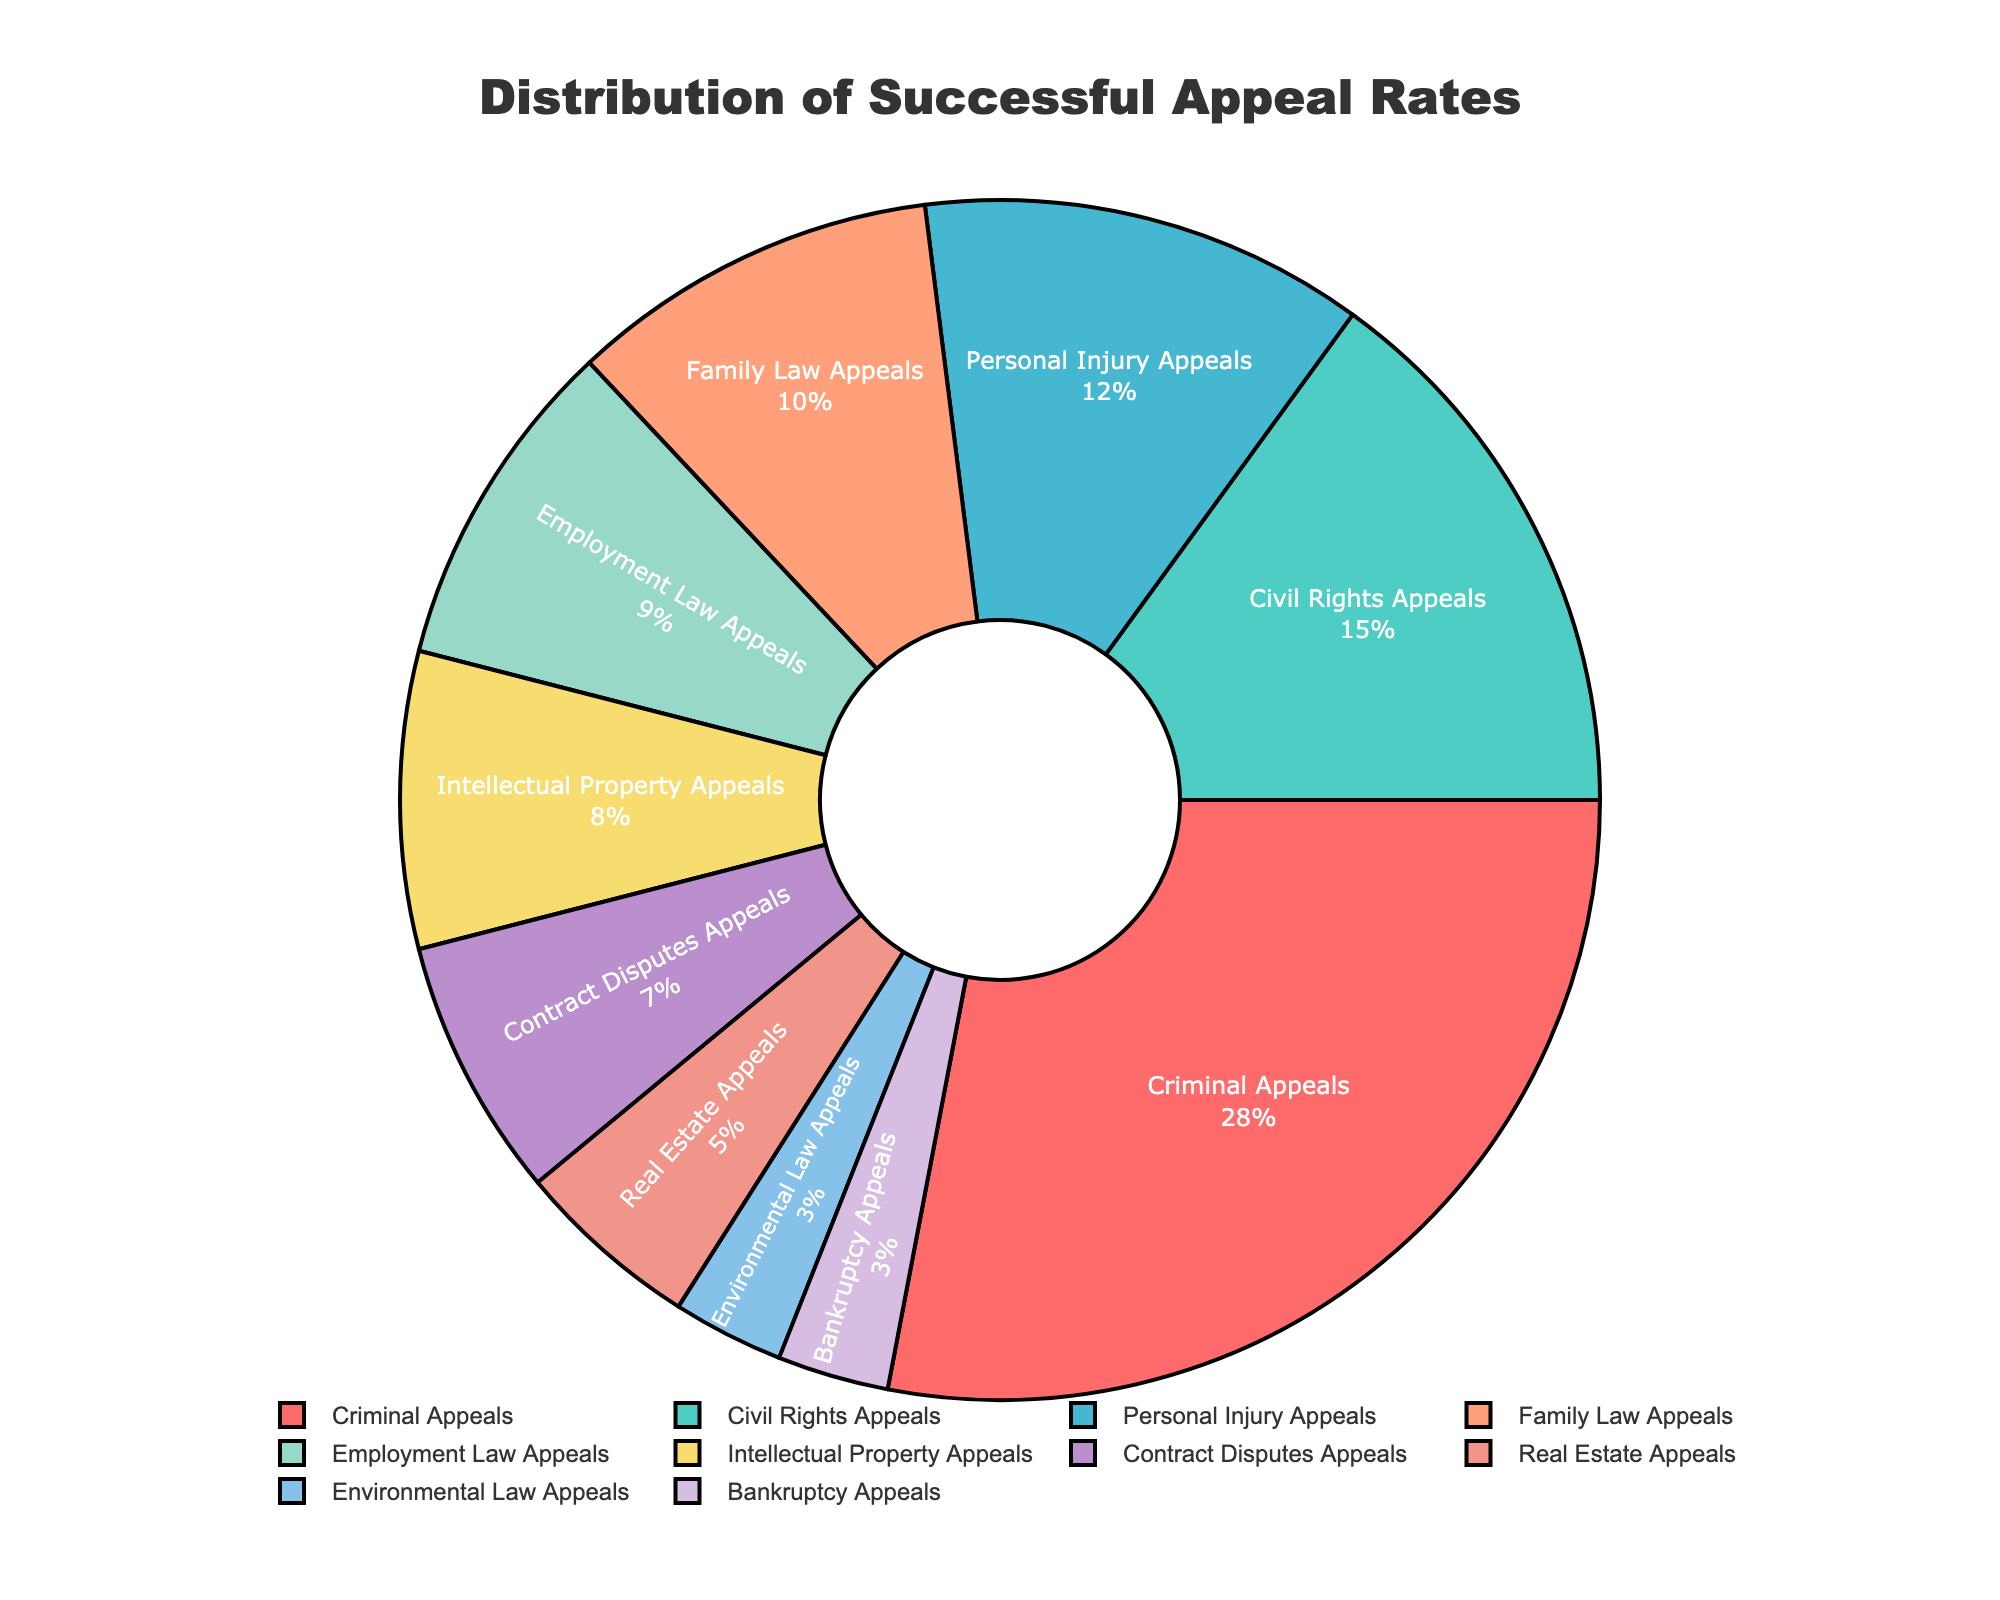what is the percentage of successful appeals in criminal cases? Look at the slice labeled "Criminal Appeals" in the pie chart. The percentage shown is 28%.
Answer: 28% Which type of legal case has the lowest percentage of successful appeals? Look for the smallest slice in the pie chart. It is labeled "Environmental Law Appeals" and "Bankruptcy Appeals," both showing 3%.
Answer: Environmental Law Appeals and Bankruptcy Appeals What is the total percentage of successful appeals for Civil Rights Appeals and Employment Law Appeals combined? Add the percentages of Civil Rights Appeals (15%) and Employment Law Appeals (9%). The sum is 15% + 9% = 24%.
Answer: 24% Which type of legal case has a higher successful appeal rate: Personal Injury Appeals or Contract Disputes Appeals? Compare the percentages of Personal Injury Appeals (12%) and Contract Disputes Appeals (7%). 12% is greater than 7%.
Answer: Personal Injury Appeals What is the combined percentage of successful appeals in Real Estate Appeals, Environmental Law Appeals, and Bankruptcy Appeals? Add the percentages of Real Estate Appeals (5%), Environmental Law Appeals (3%), and Bankruptcy Appeals (3%). The sum is 5% + 3% + 3% = 11%.
Answer: 11% By how much is the percentage of Family Law Appeals greater than Intellectual Property Appeals? Subtract the percentage of Intellectual Property Appeals (8%) from Family Law Appeals (10%). The difference is 10% - 8% = 2%.
Answer: 2% Which type of legal case has the largest slice and what is its color? The largest slice corresponds to "Criminal Appeals" and its color is red.
Answer: Criminal Appeals, red What is the total percentage of successful appeals for the categories Family Law Appeals to Contract Disputes Appeals combined? Add the percentages of Family Law Appeals (10%), Employment Law Appeals (9%), Intellectual Property Appeals (8%), and Contract Disputes Appeals (7%). The sum is 10% + 9% + 8% + 7% = 34%.
Answer: 34% Which two types of legal cases have the same percentage of successful appeals and what is that percentage? Look for slices of equal size in the pie chart. Environmental Law Appeals and Bankruptcy Appeals both have 3%.
Answer: Environmental Law Appeals and Bankruptcy Appeals, 3% What is the difference in successful appeal rates between the top two categories? The top two categories are Criminal Appeals (28%) and Civil Rights Appeals (15%). The difference is 28% - 15% = 13%.
Answer: 13% 